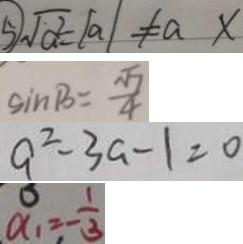<formula> <loc_0><loc_0><loc_500><loc_500>\textcircled { 5 } \sqrt { a ^ { 2 } } = \vert a \vert \neq a x 
 \sin B = \frac { \sqrt { 7 } } { 4 } 
 a ^ { 2 } - 3 a - 1 = 0 
 \alpha _ { 1 } = - \frac { 1 } { 3 }</formula> 